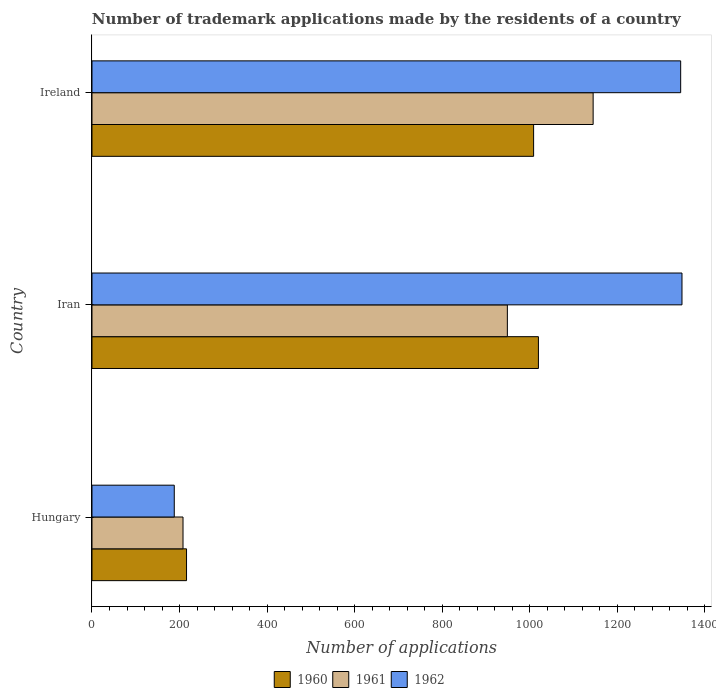How many groups of bars are there?
Keep it short and to the point. 3. Are the number of bars per tick equal to the number of legend labels?
Your response must be concise. Yes. What is the label of the 2nd group of bars from the top?
Give a very brief answer. Iran. What is the number of trademark applications made by the residents in 1961 in Hungary?
Offer a terse response. 208. Across all countries, what is the maximum number of trademark applications made by the residents in 1962?
Your response must be concise. 1348. Across all countries, what is the minimum number of trademark applications made by the residents in 1962?
Offer a very short reply. 188. In which country was the number of trademark applications made by the residents in 1962 maximum?
Your answer should be compact. Iran. In which country was the number of trademark applications made by the residents in 1960 minimum?
Give a very brief answer. Hungary. What is the total number of trademark applications made by the residents in 1962 in the graph?
Make the answer very short. 2881. What is the difference between the number of trademark applications made by the residents in 1962 in Hungary and that in Iran?
Offer a very short reply. -1160. What is the difference between the number of trademark applications made by the residents in 1960 in Hungary and the number of trademark applications made by the residents in 1962 in Iran?
Your response must be concise. -1132. What is the average number of trademark applications made by the residents in 1962 per country?
Provide a succinct answer. 960.33. What is the difference between the number of trademark applications made by the residents in 1962 and number of trademark applications made by the residents in 1960 in Iran?
Your answer should be very brief. 328. What is the ratio of the number of trademark applications made by the residents in 1962 in Hungary to that in Ireland?
Your answer should be compact. 0.14. Is the difference between the number of trademark applications made by the residents in 1962 in Iran and Ireland greater than the difference between the number of trademark applications made by the residents in 1960 in Iran and Ireland?
Your answer should be compact. No. What is the difference between the highest and the second highest number of trademark applications made by the residents in 1961?
Offer a very short reply. 196. What is the difference between the highest and the lowest number of trademark applications made by the residents in 1960?
Keep it short and to the point. 804. In how many countries, is the number of trademark applications made by the residents in 1960 greater than the average number of trademark applications made by the residents in 1960 taken over all countries?
Your answer should be compact. 2. What does the 3rd bar from the top in Hungary represents?
Your response must be concise. 1960. Are all the bars in the graph horizontal?
Offer a terse response. Yes. How many countries are there in the graph?
Provide a short and direct response. 3. Does the graph contain any zero values?
Make the answer very short. No. Where does the legend appear in the graph?
Give a very brief answer. Bottom center. How many legend labels are there?
Your answer should be very brief. 3. How are the legend labels stacked?
Offer a very short reply. Horizontal. What is the title of the graph?
Give a very brief answer. Number of trademark applications made by the residents of a country. What is the label or title of the X-axis?
Keep it short and to the point. Number of applications. What is the Number of applications in 1960 in Hungary?
Your answer should be compact. 216. What is the Number of applications of 1961 in Hungary?
Make the answer very short. 208. What is the Number of applications of 1962 in Hungary?
Your answer should be compact. 188. What is the Number of applications in 1960 in Iran?
Ensure brevity in your answer.  1020. What is the Number of applications in 1961 in Iran?
Your answer should be compact. 949. What is the Number of applications of 1962 in Iran?
Keep it short and to the point. 1348. What is the Number of applications in 1960 in Ireland?
Ensure brevity in your answer.  1009. What is the Number of applications in 1961 in Ireland?
Offer a very short reply. 1145. What is the Number of applications in 1962 in Ireland?
Keep it short and to the point. 1345. Across all countries, what is the maximum Number of applications in 1960?
Provide a succinct answer. 1020. Across all countries, what is the maximum Number of applications of 1961?
Your answer should be very brief. 1145. Across all countries, what is the maximum Number of applications of 1962?
Ensure brevity in your answer.  1348. Across all countries, what is the minimum Number of applications in 1960?
Keep it short and to the point. 216. Across all countries, what is the minimum Number of applications in 1961?
Make the answer very short. 208. Across all countries, what is the minimum Number of applications in 1962?
Provide a succinct answer. 188. What is the total Number of applications in 1960 in the graph?
Ensure brevity in your answer.  2245. What is the total Number of applications of 1961 in the graph?
Offer a terse response. 2302. What is the total Number of applications in 1962 in the graph?
Make the answer very short. 2881. What is the difference between the Number of applications in 1960 in Hungary and that in Iran?
Your response must be concise. -804. What is the difference between the Number of applications of 1961 in Hungary and that in Iran?
Offer a terse response. -741. What is the difference between the Number of applications in 1962 in Hungary and that in Iran?
Give a very brief answer. -1160. What is the difference between the Number of applications of 1960 in Hungary and that in Ireland?
Keep it short and to the point. -793. What is the difference between the Number of applications in 1961 in Hungary and that in Ireland?
Keep it short and to the point. -937. What is the difference between the Number of applications of 1962 in Hungary and that in Ireland?
Give a very brief answer. -1157. What is the difference between the Number of applications of 1961 in Iran and that in Ireland?
Provide a short and direct response. -196. What is the difference between the Number of applications in 1962 in Iran and that in Ireland?
Your answer should be compact. 3. What is the difference between the Number of applications of 1960 in Hungary and the Number of applications of 1961 in Iran?
Provide a short and direct response. -733. What is the difference between the Number of applications of 1960 in Hungary and the Number of applications of 1962 in Iran?
Provide a succinct answer. -1132. What is the difference between the Number of applications in 1961 in Hungary and the Number of applications in 1962 in Iran?
Ensure brevity in your answer.  -1140. What is the difference between the Number of applications of 1960 in Hungary and the Number of applications of 1961 in Ireland?
Give a very brief answer. -929. What is the difference between the Number of applications in 1960 in Hungary and the Number of applications in 1962 in Ireland?
Make the answer very short. -1129. What is the difference between the Number of applications of 1961 in Hungary and the Number of applications of 1962 in Ireland?
Make the answer very short. -1137. What is the difference between the Number of applications of 1960 in Iran and the Number of applications of 1961 in Ireland?
Provide a succinct answer. -125. What is the difference between the Number of applications in 1960 in Iran and the Number of applications in 1962 in Ireland?
Your answer should be compact. -325. What is the difference between the Number of applications of 1961 in Iran and the Number of applications of 1962 in Ireland?
Provide a short and direct response. -396. What is the average Number of applications of 1960 per country?
Your answer should be very brief. 748.33. What is the average Number of applications in 1961 per country?
Your answer should be compact. 767.33. What is the average Number of applications in 1962 per country?
Provide a short and direct response. 960.33. What is the difference between the Number of applications in 1960 and Number of applications in 1962 in Hungary?
Provide a short and direct response. 28. What is the difference between the Number of applications of 1961 and Number of applications of 1962 in Hungary?
Make the answer very short. 20. What is the difference between the Number of applications of 1960 and Number of applications of 1961 in Iran?
Provide a short and direct response. 71. What is the difference between the Number of applications in 1960 and Number of applications in 1962 in Iran?
Your answer should be very brief. -328. What is the difference between the Number of applications in 1961 and Number of applications in 1962 in Iran?
Provide a short and direct response. -399. What is the difference between the Number of applications of 1960 and Number of applications of 1961 in Ireland?
Offer a terse response. -136. What is the difference between the Number of applications in 1960 and Number of applications in 1962 in Ireland?
Ensure brevity in your answer.  -336. What is the difference between the Number of applications of 1961 and Number of applications of 1962 in Ireland?
Give a very brief answer. -200. What is the ratio of the Number of applications in 1960 in Hungary to that in Iran?
Provide a short and direct response. 0.21. What is the ratio of the Number of applications in 1961 in Hungary to that in Iran?
Make the answer very short. 0.22. What is the ratio of the Number of applications of 1962 in Hungary to that in Iran?
Provide a short and direct response. 0.14. What is the ratio of the Number of applications of 1960 in Hungary to that in Ireland?
Provide a short and direct response. 0.21. What is the ratio of the Number of applications in 1961 in Hungary to that in Ireland?
Make the answer very short. 0.18. What is the ratio of the Number of applications of 1962 in Hungary to that in Ireland?
Your answer should be compact. 0.14. What is the ratio of the Number of applications of 1960 in Iran to that in Ireland?
Offer a very short reply. 1.01. What is the ratio of the Number of applications of 1961 in Iran to that in Ireland?
Your response must be concise. 0.83. What is the ratio of the Number of applications in 1962 in Iran to that in Ireland?
Make the answer very short. 1. What is the difference between the highest and the second highest Number of applications in 1961?
Offer a very short reply. 196. What is the difference between the highest and the lowest Number of applications in 1960?
Your answer should be very brief. 804. What is the difference between the highest and the lowest Number of applications of 1961?
Keep it short and to the point. 937. What is the difference between the highest and the lowest Number of applications of 1962?
Your answer should be very brief. 1160. 